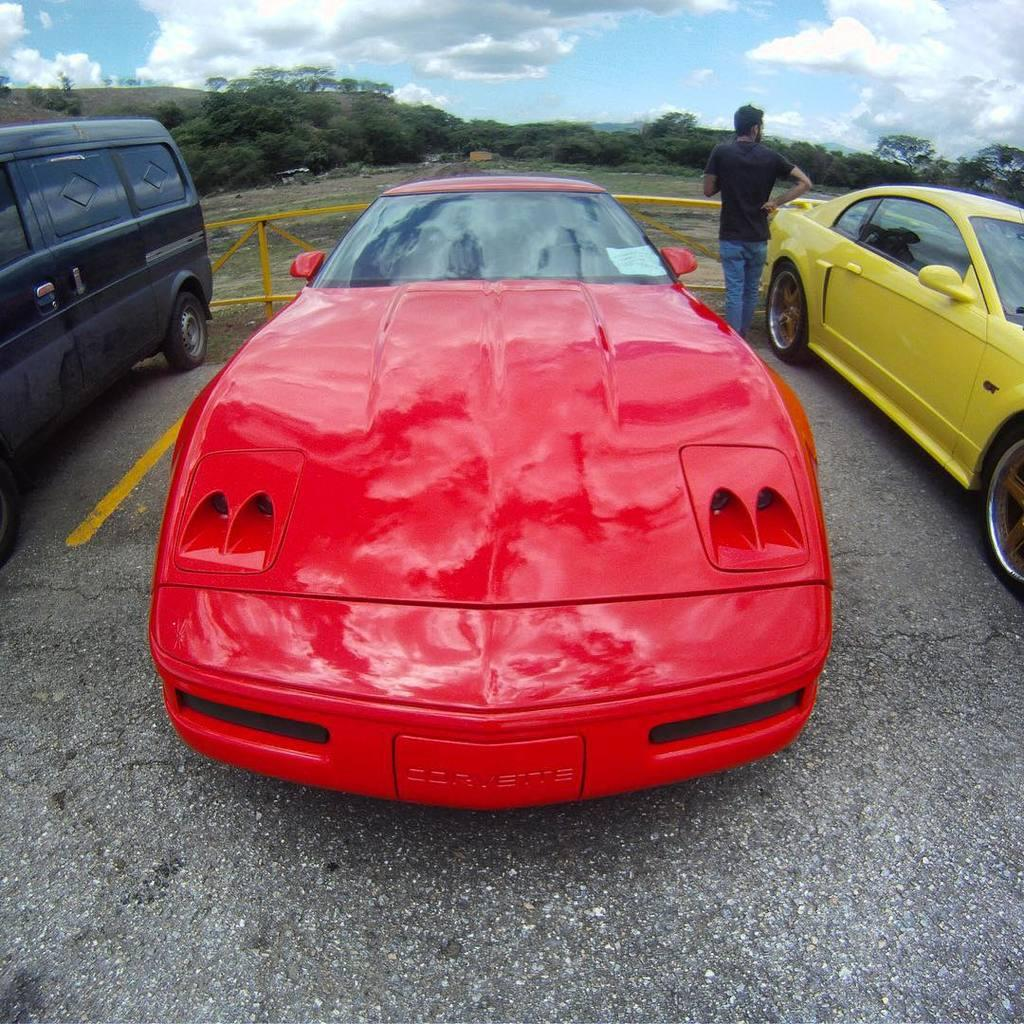How many vehicles are parked on the path in the image? There are three vehicles parked on the path in the image. Can you describe the person in the image? A person is standing in the image. What can be seen in the background of the image? There is a fence, trees, plants, the ground, and a cloudy sky visible in the background. What is the governor's opinion on the board in the image? There is no governor or board present in the image. What season is it in the image? The provided facts do not mention the season, so it cannot be determined from the image. 